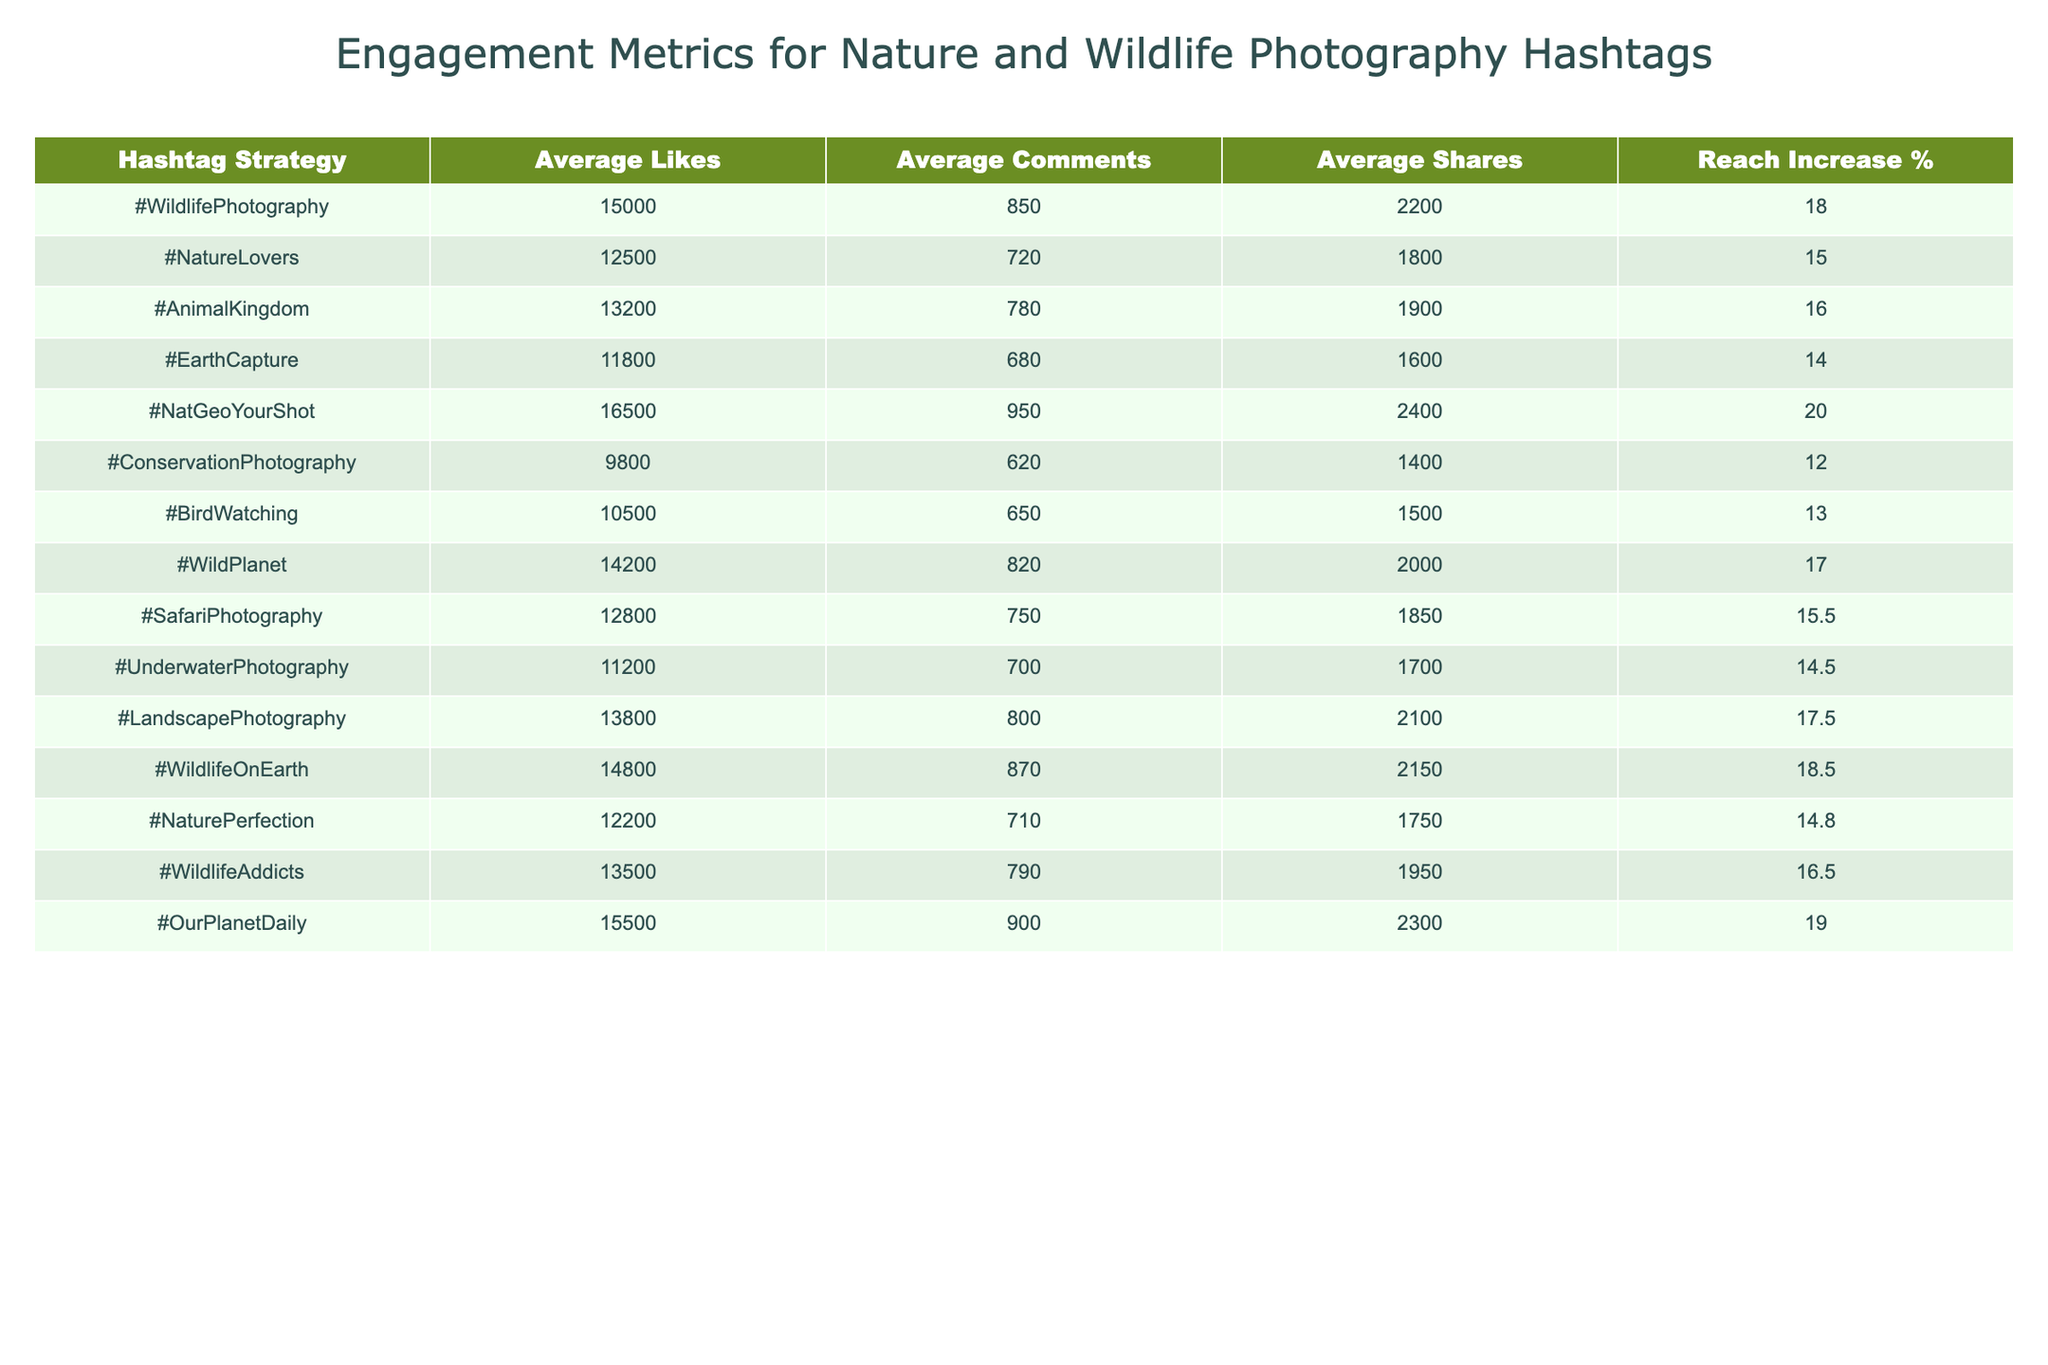What is the average number of likes for the hashtag #WildlifePhotography? The table shows that the average likes for #WildlifePhotography is 15,000.
Answer: 15,000 Which hashtag strategy received the highest average number of comments? Checking the comments column, #NatGeoYourShot has the highest average comments at 950.
Answer: 950 What is the reach increase percentage for #ConservationPhotography? The table reveals that the reach increase percentage for #ConservationPhotography is 12%.
Answer: 12% How many average shares does the hashtag #BirdWatching receive? According to the table, #BirdWatching has an average of 1,500 shares.
Answer: 1,500 Which hashtag has the lowest average likes, and what is that value? By examining the average likes column, #ConservationPhotography has the lowest average likes at 9,800.
Answer: 9,800 What is the difference in reach increase percentage between #EarthCapture and #LandscapePhotography? #EarthCapture has a reach increase of 14%, while #LandscapePhotography has 17.5%. The difference is 17.5% - 14% = 3.5%.
Answer: 3.5% Which hashtag strategy has an average number of shares greater than 2,000 and what are those hashtags? Looking at the shares column, #NatGeoYourShot, #OurPlanetDaily, and #WildlifeOnEarth all have shares greater than 2,000: 2,400, 2,300, and 2,150 respectively.
Answer: #NatGeoYourShot, #OurPlanetDaily, #WildlifeOnEarth Calculate the average likes for hashtags that include the word "Wildlife." The hashtags with "Wildlife" are #WildlifePhotography (15,000), #WildlifeOnEarth (14,800), and #WildlifeAddicts (13,500). The average is (15,000 + 14,800 + 13,500) / 3 = 14,433.33.
Answer: 14,433.33 Does the hashtag strategy #AnimalKingdom have a higher average of comments than #NaturePerfection? #AnimalKingdom has an average of 780 comments, while #NaturePerfection has 710 comments; thus, #AnimalKingdom does have a higher average.
Answer: Yes What is the total of average likes for all hashtags in the table? Summing all average likes: 15,000 + 12,500 + 13,200 + 11,800 + 16,500 + 9,800 + 10,500 + 14,200 + 12,800 + 11,200 + 13,800 + 14,800 + 12,200 + 13,500 + 15,500 = 200,300. Therefore, average likes total = 200,300.
Answer: 200,300 